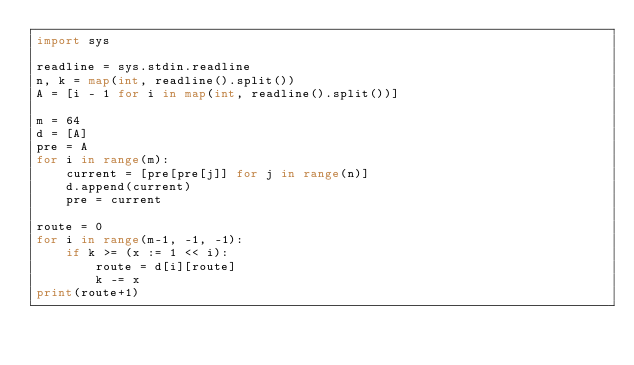<code> <loc_0><loc_0><loc_500><loc_500><_Python_>import sys

readline = sys.stdin.readline
n, k = map(int, readline().split())
A = [i - 1 for i in map(int, readline().split())]

m = 64
d = [A]
pre = A
for i in range(m):
    current = [pre[pre[j]] for j in range(n)]
    d.append(current)
    pre = current

route = 0
for i in range(m-1, -1, -1):
    if k >= (x := 1 << i):
        route = d[i][route]
        k -= x
print(route+1)
</code> 